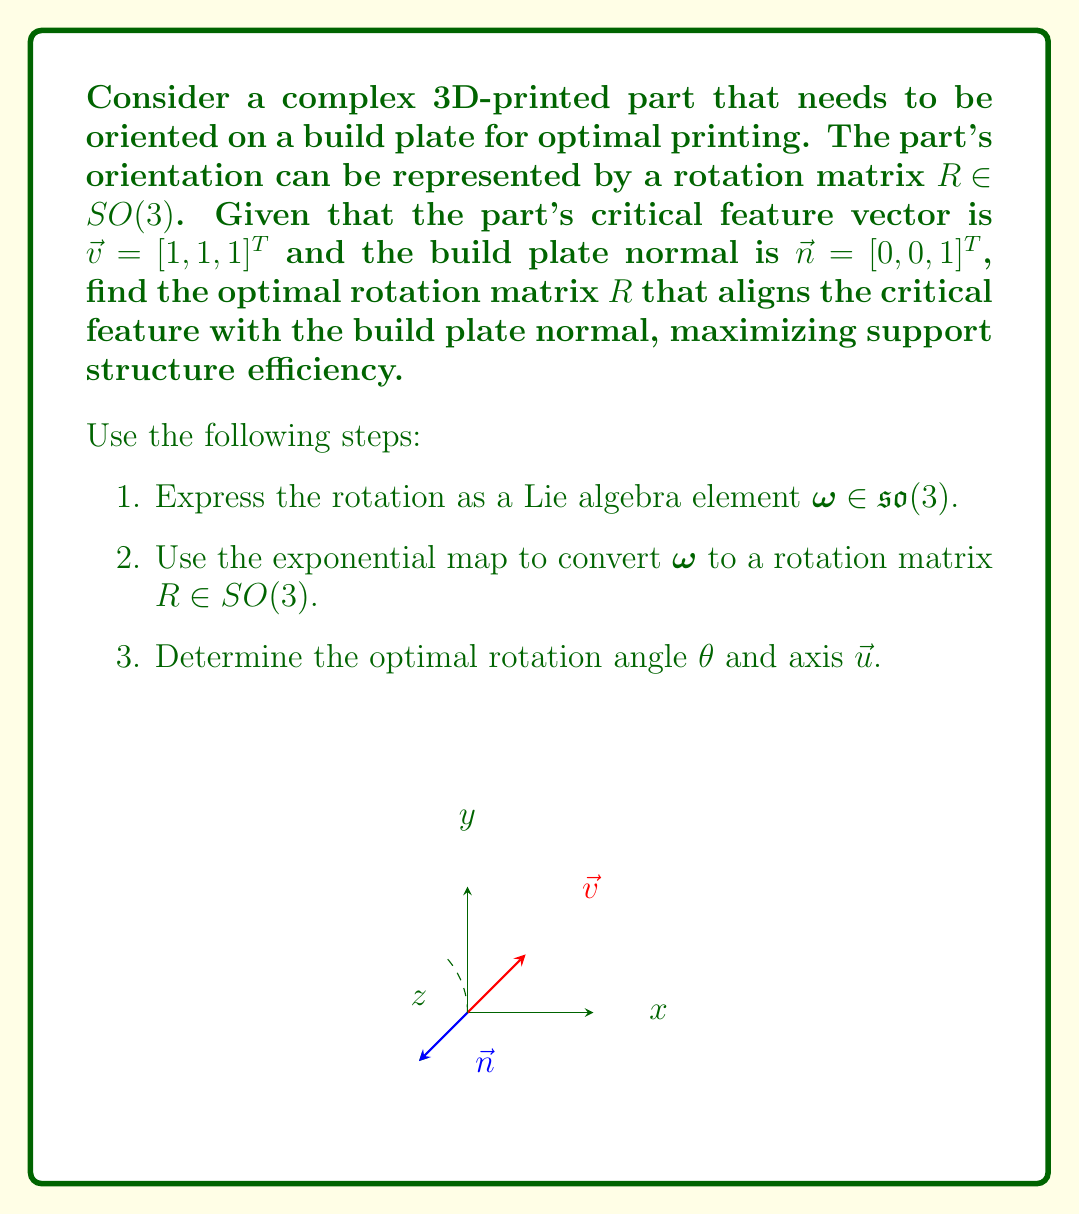Solve this math problem. 1. To find the optimal rotation, we need to rotate $\vec{v}$ to align with $\vec{n}$. The rotation axis $\vec{u}$ is perpendicular to both vectors:

   $\vec{u} = \vec{v} \times \vec{n} = [1, 1, 1]^T \times [0, 0, 1]^T = [-1, 1, 0]^T$

   Normalize $\vec{u}$:
   $\vec{u} = \frac{1}{\sqrt{2}}[-1, 1, 0]^T$

2. The rotation angle $\theta$ is given by:
   
   $\cos \theta = \frac{\vec{v} \cdot \vec{n}}{|\vec{v}||\vec{n}|} = \frac{1}{\sqrt{3}}$

   $\theta = \arccos(\frac{1}{\sqrt{3}}) \approx 0.9553$ radians

3. The Lie algebra element $\omega \in \mathfrak{so}(3)$ is given by:

   $\omega = \theta \hat{u} = \theta \begin{bmatrix} 0 & 0 & \frac{1}{\sqrt{2}} \\ 0 & 0 & \frac{1}{\sqrt{2}} \\ -\frac{1}{\sqrt{2}} & -\frac{1}{\sqrt{2}} & 0 \end{bmatrix}$

4. Using the exponential map, we can convert $\omega$ to a rotation matrix $R \in SO(3)$:

   $R = \exp(\omega) = I + \sin\theta \hat{u} + (1-\cos\theta)\hat{u}^2$

   Where $I$ is the 3x3 identity matrix, and $\hat{u}$ is the skew-symmetric matrix of $\vec{u}$.

5. Calculating $R$:

   $R = \begin{bmatrix} 
   \frac{1}{3} + \frac{2\sqrt{2}}{3}\sin\theta + \frac{2}{3}\cos\theta & 
   \frac{1}{3} - \frac{\sqrt{2}}{3}\sin\theta - \frac{1}{3}\cos\theta & 
   \frac{1}{3} + \frac{\sqrt{2}}{3}\sin\theta - \frac{1}{3}\cos\theta \\
   \frac{1}{3} - \frac{\sqrt{2}}{3}\sin\theta - \frac{1}{3}\cos\theta & 
   \frac{1}{3} + \frac{2\sqrt{2}}{3}\sin\theta + \frac{2}{3}\cos\theta & 
   \frac{1}{3} - \frac{\sqrt{2}}{3}\sin\theta - \frac{1}{3}\cos\theta \\
   \frac{1}{3} + \frac{\sqrt{2}}{3}\sin\theta - \frac{1}{3}\cos\theta & 
   \frac{1}{3} - \frac{\sqrt{2}}{3}\sin\theta - \frac{1}{3}\cos\theta & 
   \frac{1}{3} + \frac{2}{3}\cos\theta 
   \end{bmatrix}$

This rotation matrix $R$ represents the optimal orientation of the 3D-printed part on the build plate.
Answer: $R = \begin{bmatrix} 
\frac{1}{3} + \frac{2\sqrt{2}}{3}\sin\theta + \frac{2}{3}\cos\theta & 
\frac{1}{3} - \frac{\sqrt{2}}{3}\sin\theta - \frac{1}{3}\cos\theta & 
\frac{1}{3} + \frac{\sqrt{2}}{3}\sin\theta - \frac{1}{3}\cos\theta \\
\frac{1}{3} - \frac{\sqrt{2}}{3}\sin\theta - \frac{1}{3}\cos\theta & 
\frac{1}{3} + \frac{2\sqrt{2}}{3}\sin\theta + \frac{2}{3}\cos\theta & 
\frac{1}{3} - \frac{\sqrt{2}}{3}\sin\theta - \frac{1}{3}\cos\theta \\
\frac{1}{3} + \frac{\sqrt{2}}{3}\sin\theta - \frac{1}{3}\cos\theta & 
\frac{1}{3} - \frac{\sqrt{2}}{3}\sin\theta - \frac{1}{3}\cos\theta & 
\frac{1}{3} + \frac{2}{3}\cos\theta 
\end{bmatrix}$, where $\theta = \arccos(\frac{1}{\sqrt{3}})$ 